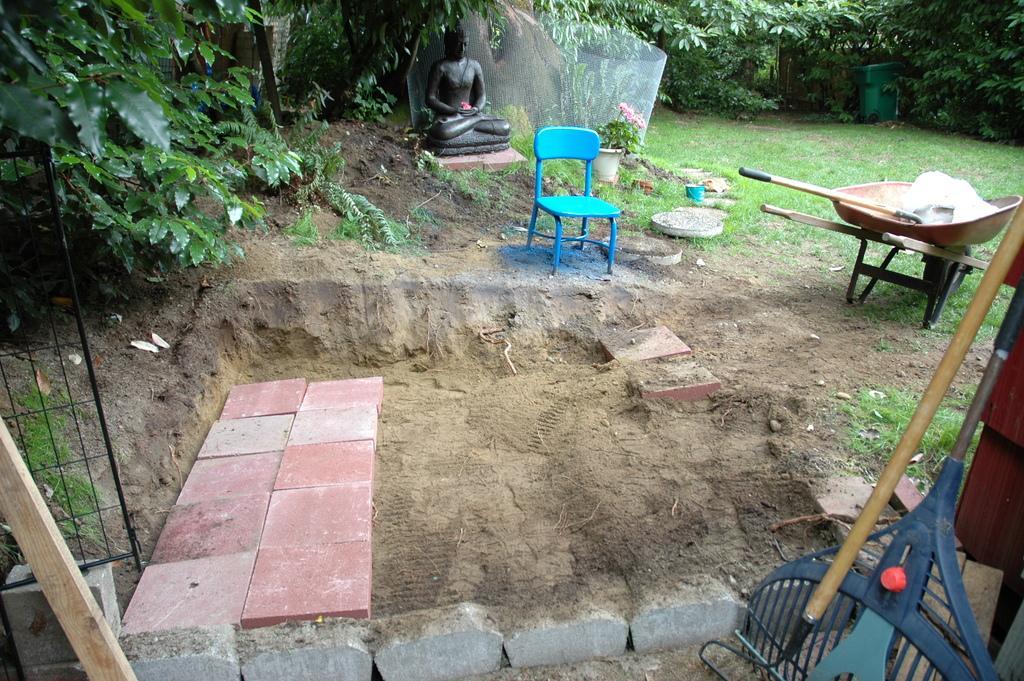Please provide a concise description of this image. There is a wooden stick on the left. There is sand and red tiles on the ground. There is a blue chair and a sculpture at the center back. There are trees at the back and wooden stands on the right. 